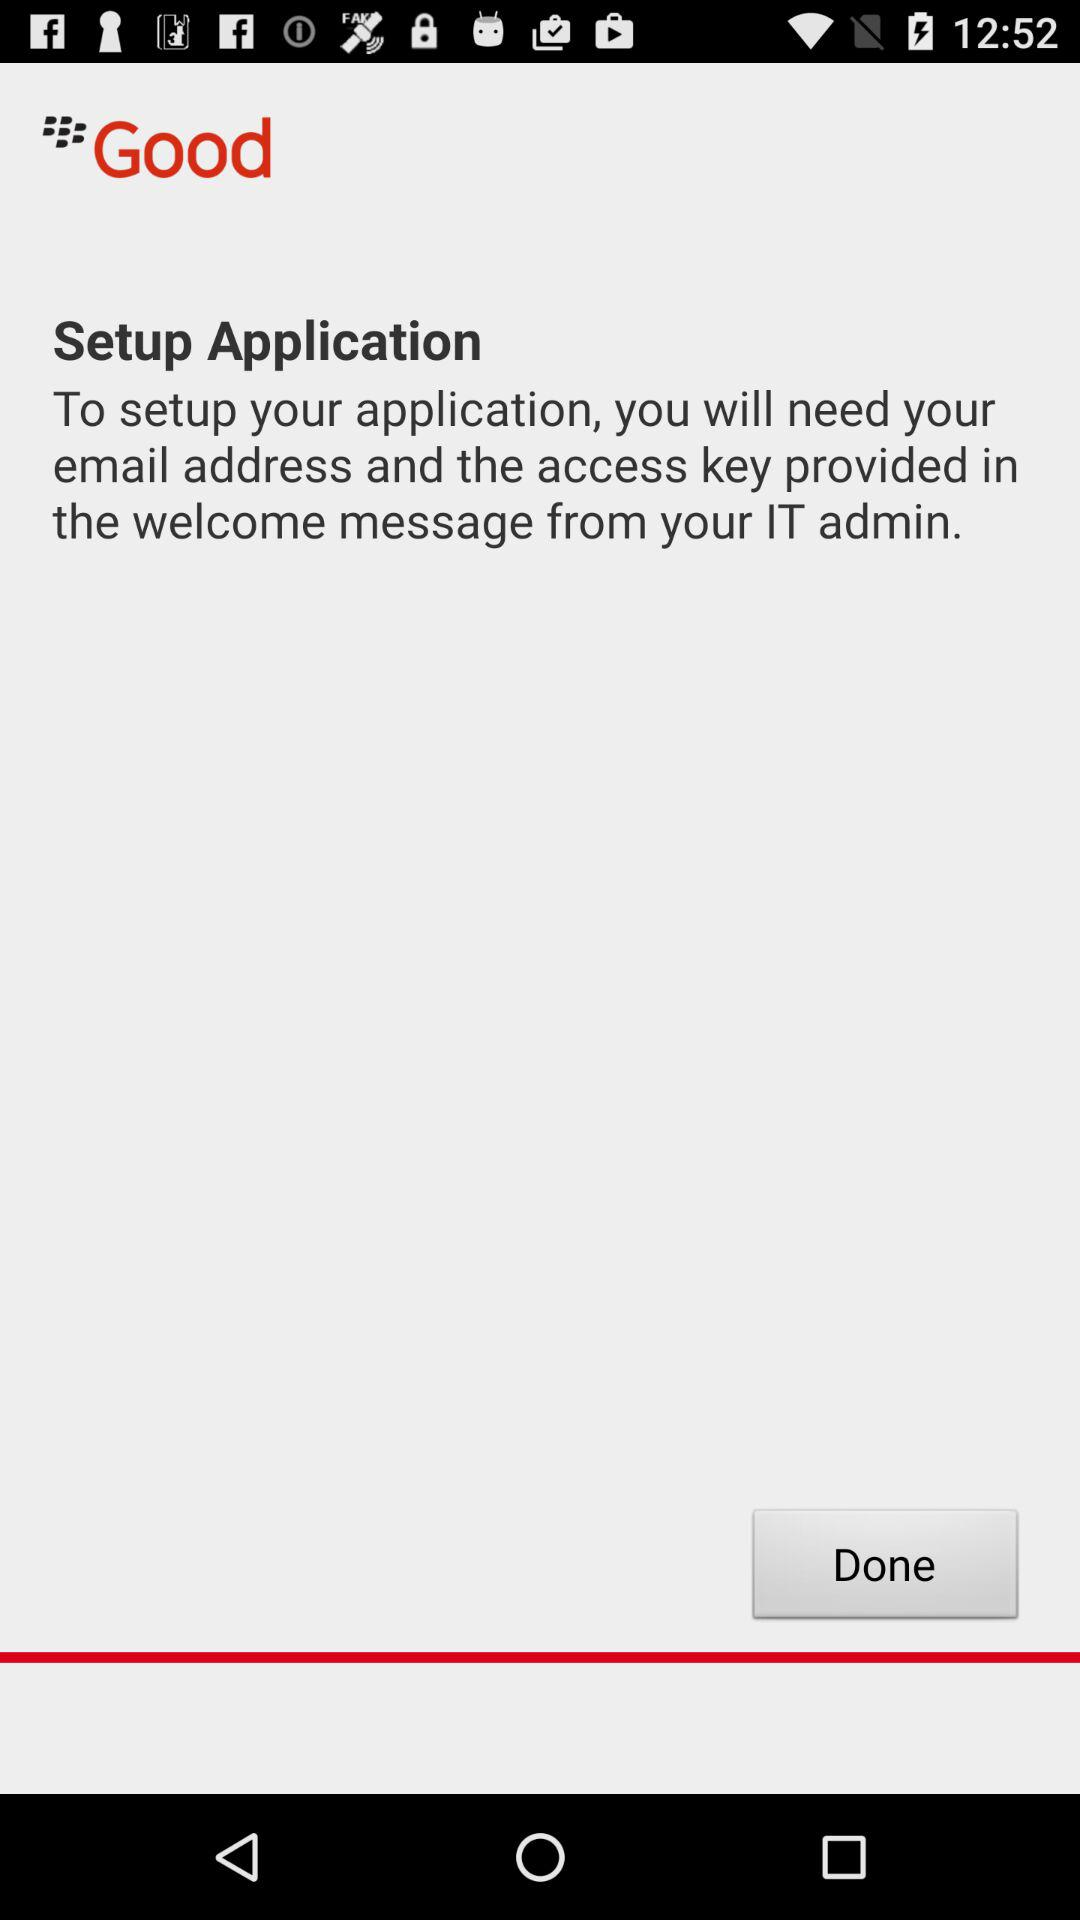What are the needs to set up the application? The needs to set up the application are your email address and the access key provided in the welcome message from your IT admin. 